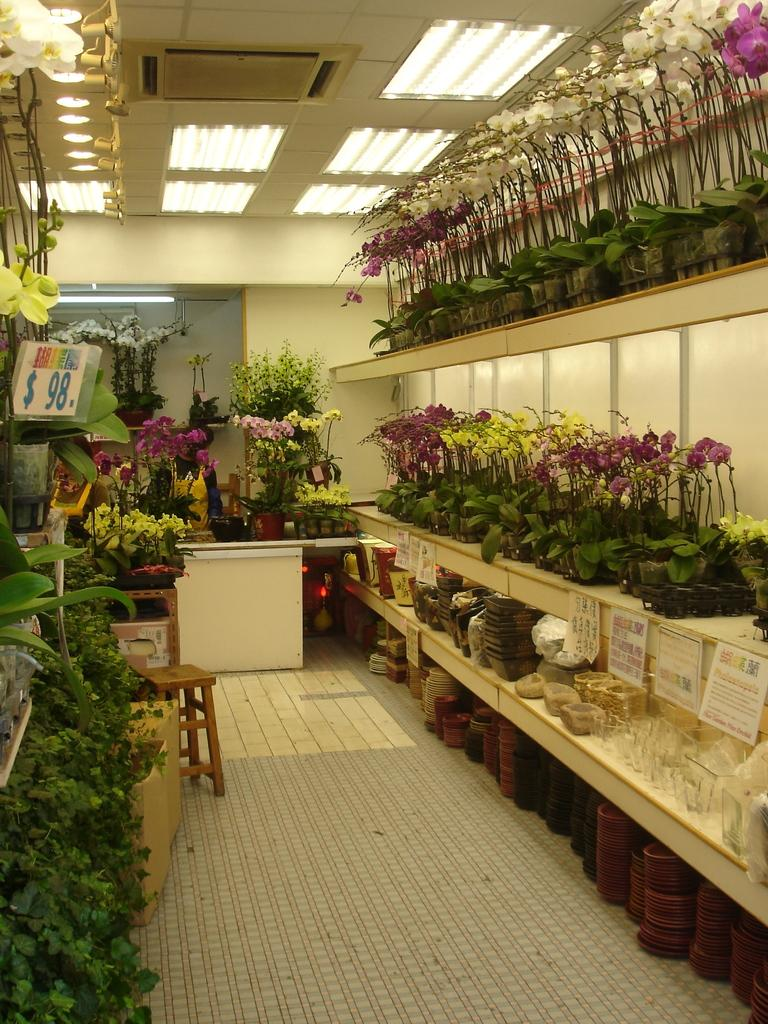What can be seen in the image that is related to plants? There are many flower pots in the image. Where are the flower pots located? The flower pots are placed on shelves. What is the purpose of the flower pots in the image? The flower pots are for sale. What piece of furniture is on the floor in the image? There is a stool on the floor. What type of cooling system is present in the image? There is a central air conditioner in the image. What is used to illuminate the room in the image? Lights are fixed to the ceiling. Where is the faucet located in the image? There is no faucet present in the image. What type of bird can be seen perched on the flower pots in the image? There are no birds, including crows, present in the image. 